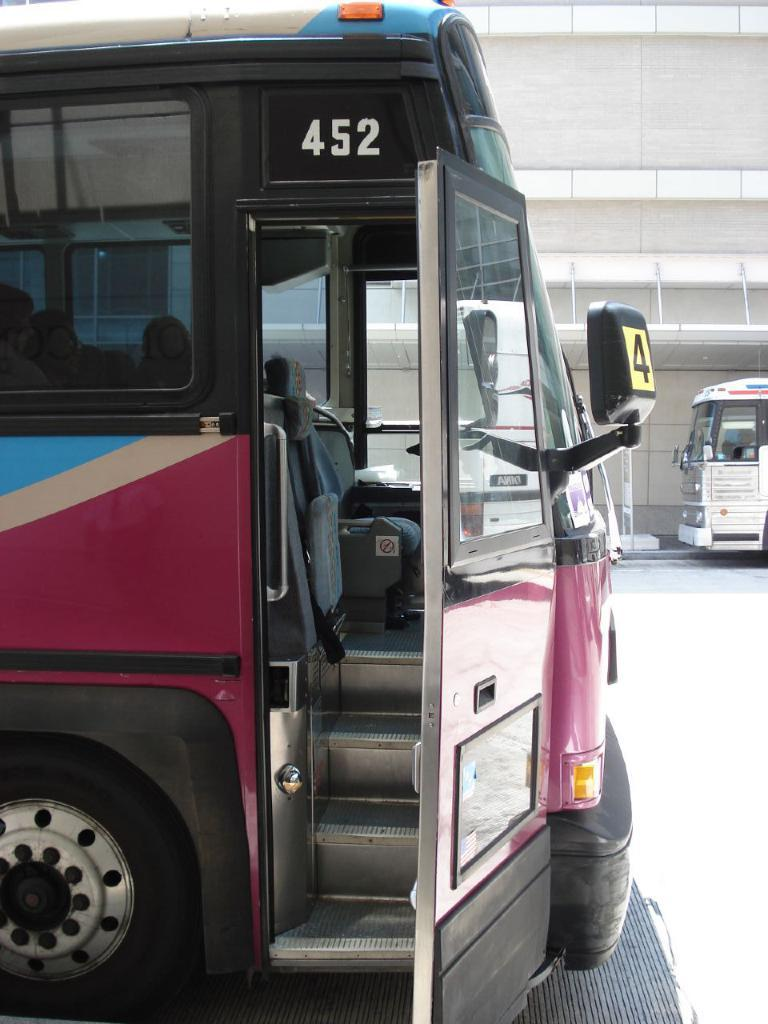<image>
Present a compact description of the photo's key features. a bus with the number 452 above the door 